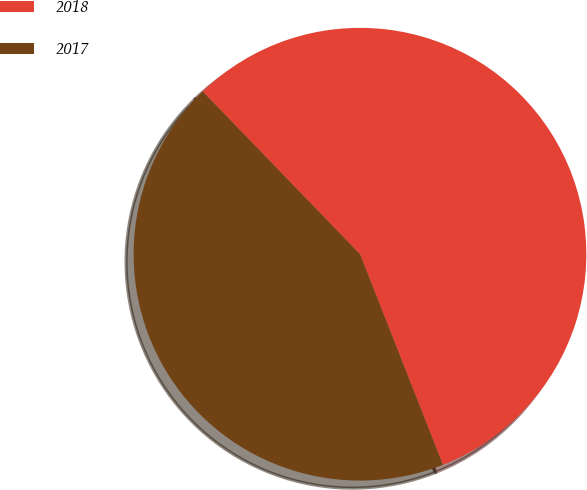<chart> <loc_0><loc_0><loc_500><loc_500><pie_chart><fcel>2018<fcel>2017<nl><fcel>56.26%<fcel>43.74%<nl></chart> 